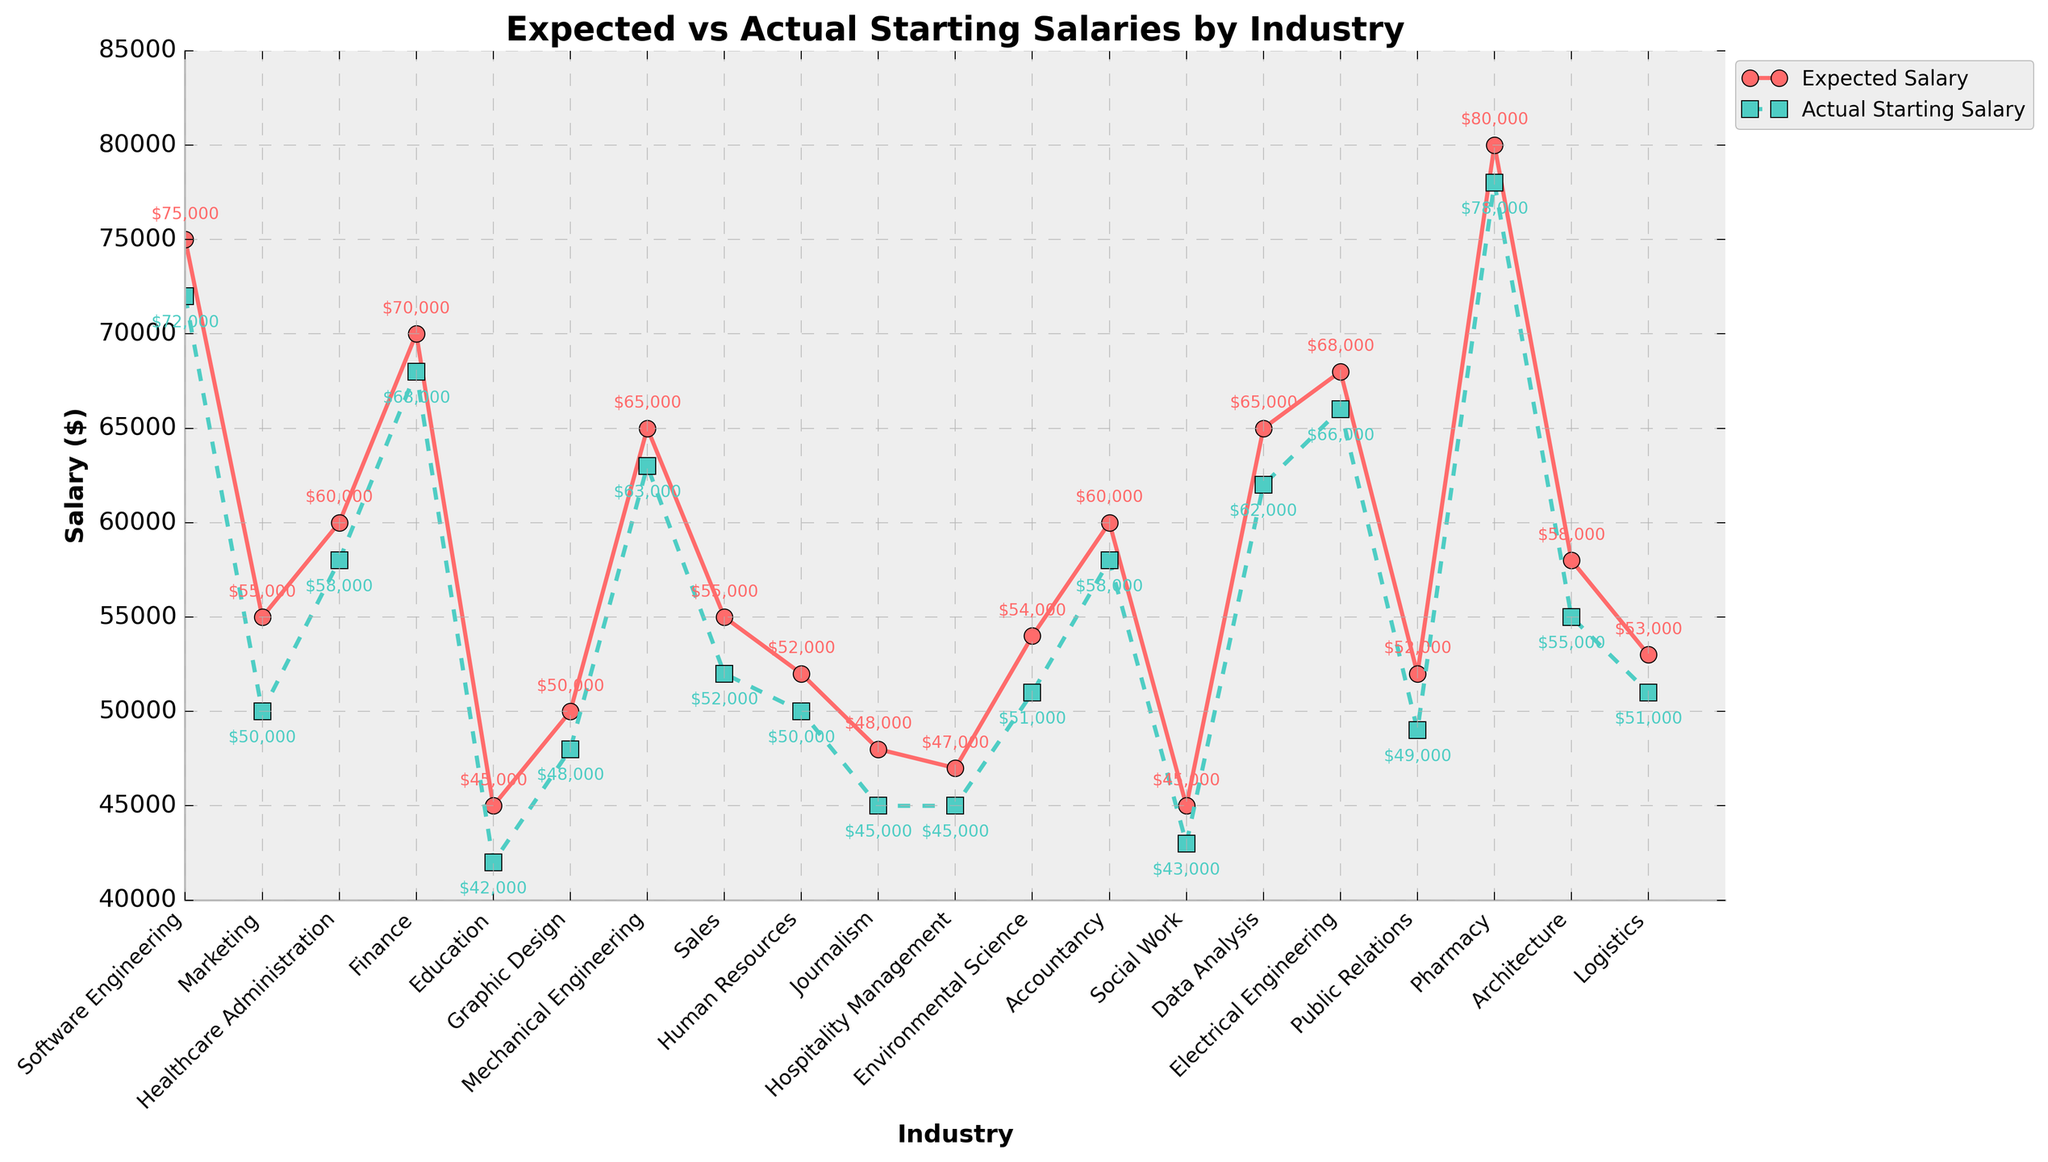What is the difference between the expected and actual starting salaries for Software Engineering? Locate the expected salary for Software Engineering on the red line, which is $75,000. Then find the actual salary on the green line, which is $72,000. Subtract the actual salary from the expected salary: $75,000 - $72,000 = $3,000.
Answer: $3,000 Which industry has the smallest difference between expected and actual starting salaries? Compare the differences between the expected and actual salaries for each industry. The smallest difference is $2,000, seen in Pharmacy, where expected is $80,000 and actual is $78,000.
Answer: Pharmacy How much higher is the expected salary than the actual salary for Marketing? Find the expected salary for Marketing at $55,000 and the actual salary at $50,000. Subtract the actual from the expected: $55,000 - $50,000 = $5,000.
Answer: $5,000 What are the expected and actual starting salaries for Data Analysis? Locate Data Analysis on the x-axis and refer to the red line for the expected salary ($65,000) and the green line for the actual salary ($62,000).
Answer: Expected: $65,000; Actual: $62,000 Which industry shows the greatest drop from expected to actual starting salaries? Identify the industry with the largest gap between expected and actual salaries. Journalism has the largest drop, from $48,000 to $45,000, a difference of $3,000.
Answer: Journalism Are the actual starting salaries for Education and Social Work higher or lower than expected? Compare the actual salaries to the expected salaries for Education and Social Work. Both actual salaries ($42,000 for Education and $43,000 for Social Work) are lower than expected ($45,000 for Education and $45,000 for Social Work).
Answer: Lower Find the average actual starting salary for the industries Finance and Mechanical Engineering. Locate the actual salaries for Finance ($68,000) and Mechanical Engineering ($63,000). Sum them and divide by 2: ($68,000 + $63,000) / 2 = $65,500.
Answer: $65,500 Which industry has the closest actual starting salary to its expected value? Identify the industry where the expected and actual values are nearest. Pharmacy has the closest values with a difference of $2,000 ($80,000 expected, $78,000 actual).
Answer: Pharmacy Compare the expected starting salary trends for Software Engineering and Electrical Engineering. Follow the red line for both industries. Software Engineering's expected salary is $75,000, and Electrical Engineering is $68,000, indicating Software Engineering has a higher expected salary.
Answer: Software Engineering has a higher expected salary Between Mechanical Engineering and Data Analysis, which has a higher actual starting salary? Locate the actual starting salaries on the green line for both industries. Mechanical Engineering has $63,000 and Data Analysis has $62,000, so Mechanical Engineering has a higher actual salary.
Answer: Mechanical Engineering has a higher actual salary 